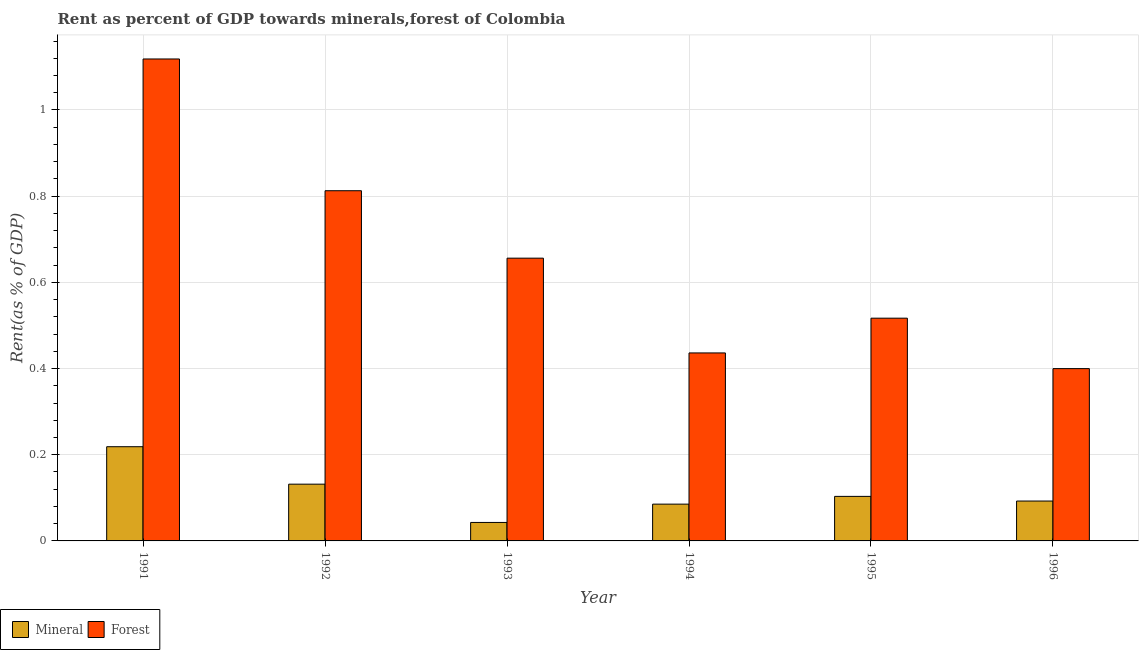How many different coloured bars are there?
Ensure brevity in your answer.  2. Are the number of bars on each tick of the X-axis equal?
Offer a very short reply. Yes. How many bars are there on the 2nd tick from the left?
Make the answer very short. 2. How many bars are there on the 2nd tick from the right?
Your response must be concise. 2. In how many cases, is the number of bars for a given year not equal to the number of legend labels?
Keep it short and to the point. 0. What is the mineral rent in 1992?
Keep it short and to the point. 0.13. Across all years, what is the maximum mineral rent?
Your answer should be compact. 0.22. Across all years, what is the minimum forest rent?
Offer a terse response. 0.4. In which year was the mineral rent maximum?
Ensure brevity in your answer.  1991. In which year was the forest rent minimum?
Your answer should be compact. 1996. What is the total mineral rent in the graph?
Provide a short and direct response. 0.67. What is the difference between the forest rent in 1994 and that in 1995?
Keep it short and to the point. -0.08. What is the difference between the forest rent in 1991 and the mineral rent in 1992?
Your answer should be compact. 0.31. What is the average forest rent per year?
Offer a very short reply. 0.66. What is the ratio of the forest rent in 1992 to that in 1994?
Your response must be concise. 1.86. Is the mineral rent in 1993 less than that in 1994?
Offer a terse response. Yes. Is the difference between the forest rent in 1991 and 1996 greater than the difference between the mineral rent in 1991 and 1996?
Provide a succinct answer. No. What is the difference between the highest and the second highest mineral rent?
Provide a succinct answer. 0.09. What is the difference between the highest and the lowest mineral rent?
Keep it short and to the point. 0.18. Is the sum of the mineral rent in 1991 and 1994 greater than the maximum forest rent across all years?
Give a very brief answer. Yes. What does the 2nd bar from the left in 1994 represents?
Give a very brief answer. Forest. What does the 2nd bar from the right in 1996 represents?
Offer a very short reply. Mineral. Are all the bars in the graph horizontal?
Your response must be concise. No. How many years are there in the graph?
Make the answer very short. 6. Are the values on the major ticks of Y-axis written in scientific E-notation?
Ensure brevity in your answer.  No. What is the title of the graph?
Offer a very short reply. Rent as percent of GDP towards minerals,forest of Colombia. Does "% of gross capital formation" appear as one of the legend labels in the graph?
Provide a short and direct response. No. What is the label or title of the Y-axis?
Give a very brief answer. Rent(as % of GDP). What is the Rent(as % of GDP) of Mineral in 1991?
Give a very brief answer. 0.22. What is the Rent(as % of GDP) in Forest in 1991?
Offer a terse response. 1.12. What is the Rent(as % of GDP) in Mineral in 1992?
Provide a succinct answer. 0.13. What is the Rent(as % of GDP) in Forest in 1992?
Provide a short and direct response. 0.81. What is the Rent(as % of GDP) in Mineral in 1993?
Provide a succinct answer. 0.04. What is the Rent(as % of GDP) of Forest in 1993?
Provide a short and direct response. 0.66. What is the Rent(as % of GDP) in Mineral in 1994?
Offer a very short reply. 0.09. What is the Rent(as % of GDP) of Forest in 1994?
Offer a terse response. 0.44. What is the Rent(as % of GDP) of Mineral in 1995?
Your response must be concise. 0.1. What is the Rent(as % of GDP) of Forest in 1995?
Provide a succinct answer. 0.52. What is the Rent(as % of GDP) of Mineral in 1996?
Your response must be concise. 0.09. What is the Rent(as % of GDP) in Forest in 1996?
Offer a very short reply. 0.4. Across all years, what is the maximum Rent(as % of GDP) of Mineral?
Keep it short and to the point. 0.22. Across all years, what is the maximum Rent(as % of GDP) in Forest?
Your answer should be compact. 1.12. Across all years, what is the minimum Rent(as % of GDP) in Mineral?
Provide a succinct answer. 0.04. Across all years, what is the minimum Rent(as % of GDP) in Forest?
Offer a terse response. 0.4. What is the total Rent(as % of GDP) in Mineral in the graph?
Make the answer very short. 0.67. What is the total Rent(as % of GDP) in Forest in the graph?
Your response must be concise. 3.94. What is the difference between the Rent(as % of GDP) of Mineral in 1991 and that in 1992?
Offer a very short reply. 0.09. What is the difference between the Rent(as % of GDP) in Forest in 1991 and that in 1992?
Your response must be concise. 0.31. What is the difference between the Rent(as % of GDP) of Mineral in 1991 and that in 1993?
Offer a very short reply. 0.18. What is the difference between the Rent(as % of GDP) in Forest in 1991 and that in 1993?
Offer a very short reply. 0.46. What is the difference between the Rent(as % of GDP) in Mineral in 1991 and that in 1994?
Offer a very short reply. 0.13. What is the difference between the Rent(as % of GDP) of Forest in 1991 and that in 1994?
Your response must be concise. 0.68. What is the difference between the Rent(as % of GDP) of Mineral in 1991 and that in 1995?
Give a very brief answer. 0.12. What is the difference between the Rent(as % of GDP) in Forest in 1991 and that in 1995?
Keep it short and to the point. 0.6. What is the difference between the Rent(as % of GDP) in Mineral in 1991 and that in 1996?
Your answer should be compact. 0.13. What is the difference between the Rent(as % of GDP) of Forest in 1991 and that in 1996?
Offer a terse response. 0.72. What is the difference between the Rent(as % of GDP) of Mineral in 1992 and that in 1993?
Your answer should be very brief. 0.09. What is the difference between the Rent(as % of GDP) of Forest in 1992 and that in 1993?
Ensure brevity in your answer.  0.16. What is the difference between the Rent(as % of GDP) of Mineral in 1992 and that in 1994?
Your response must be concise. 0.05. What is the difference between the Rent(as % of GDP) of Forest in 1992 and that in 1994?
Ensure brevity in your answer.  0.38. What is the difference between the Rent(as % of GDP) of Mineral in 1992 and that in 1995?
Keep it short and to the point. 0.03. What is the difference between the Rent(as % of GDP) in Forest in 1992 and that in 1995?
Keep it short and to the point. 0.3. What is the difference between the Rent(as % of GDP) in Mineral in 1992 and that in 1996?
Offer a terse response. 0.04. What is the difference between the Rent(as % of GDP) in Forest in 1992 and that in 1996?
Provide a short and direct response. 0.41. What is the difference between the Rent(as % of GDP) in Mineral in 1993 and that in 1994?
Ensure brevity in your answer.  -0.04. What is the difference between the Rent(as % of GDP) of Forest in 1993 and that in 1994?
Ensure brevity in your answer.  0.22. What is the difference between the Rent(as % of GDP) of Mineral in 1993 and that in 1995?
Offer a very short reply. -0.06. What is the difference between the Rent(as % of GDP) in Forest in 1993 and that in 1995?
Keep it short and to the point. 0.14. What is the difference between the Rent(as % of GDP) of Mineral in 1993 and that in 1996?
Your response must be concise. -0.05. What is the difference between the Rent(as % of GDP) of Forest in 1993 and that in 1996?
Offer a very short reply. 0.26. What is the difference between the Rent(as % of GDP) in Mineral in 1994 and that in 1995?
Give a very brief answer. -0.02. What is the difference between the Rent(as % of GDP) in Forest in 1994 and that in 1995?
Make the answer very short. -0.08. What is the difference between the Rent(as % of GDP) in Mineral in 1994 and that in 1996?
Ensure brevity in your answer.  -0.01. What is the difference between the Rent(as % of GDP) of Forest in 1994 and that in 1996?
Your response must be concise. 0.04. What is the difference between the Rent(as % of GDP) of Mineral in 1995 and that in 1996?
Your answer should be very brief. 0.01. What is the difference between the Rent(as % of GDP) of Forest in 1995 and that in 1996?
Give a very brief answer. 0.12. What is the difference between the Rent(as % of GDP) in Mineral in 1991 and the Rent(as % of GDP) in Forest in 1992?
Offer a very short reply. -0.59. What is the difference between the Rent(as % of GDP) in Mineral in 1991 and the Rent(as % of GDP) in Forest in 1993?
Offer a terse response. -0.44. What is the difference between the Rent(as % of GDP) of Mineral in 1991 and the Rent(as % of GDP) of Forest in 1994?
Your answer should be very brief. -0.22. What is the difference between the Rent(as % of GDP) in Mineral in 1991 and the Rent(as % of GDP) in Forest in 1995?
Provide a succinct answer. -0.3. What is the difference between the Rent(as % of GDP) of Mineral in 1991 and the Rent(as % of GDP) of Forest in 1996?
Keep it short and to the point. -0.18. What is the difference between the Rent(as % of GDP) of Mineral in 1992 and the Rent(as % of GDP) of Forest in 1993?
Provide a succinct answer. -0.52. What is the difference between the Rent(as % of GDP) in Mineral in 1992 and the Rent(as % of GDP) in Forest in 1994?
Provide a succinct answer. -0.3. What is the difference between the Rent(as % of GDP) of Mineral in 1992 and the Rent(as % of GDP) of Forest in 1995?
Provide a succinct answer. -0.39. What is the difference between the Rent(as % of GDP) in Mineral in 1992 and the Rent(as % of GDP) in Forest in 1996?
Provide a short and direct response. -0.27. What is the difference between the Rent(as % of GDP) of Mineral in 1993 and the Rent(as % of GDP) of Forest in 1994?
Offer a very short reply. -0.39. What is the difference between the Rent(as % of GDP) in Mineral in 1993 and the Rent(as % of GDP) in Forest in 1995?
Ensure brevity in your answer.  -0.47. What is the difference between the Rent(as % of GDP) in Mineral in 1993 and the Rent(as % of GDP) in Forest in 1996?
Your response must be concise. -0.36. What is the difference between the Rent(as % of GDP) in Mineral in 1994 and the Rent(as % of GDP) in Forest in 1995?
Your response must be concise. -0.43. What is the difference between the Rent(as % of GDP) in Mineral in 1994 and the Rent(as % of GDP) in Forest in 1996?
Keep it short and to the point. -0.31. What is the difference between the Rent(as % of GDP) in Mineral in 1995 and the Rent(as % of GDP) in Forest in 1996?
Provide a succinct answer. -0.3. What is the average Rent(as % of GDP) of Mineral per year?
Provide a short and direct response. 0.11. What is the average Rent(as % of GDP) in Forest per year?
Make the answer very short. 0.66. In the year 1991, what is the difference between the Rent(as % of GDP) in Mineral and Rent(as % of GDP) in Forest?
Offer a terse response. -0.9. In the year 1992, what is the difference between the Rent(as % of GDP) in Mineral and Rent(as % of GDP) in Forest?
Keep it short and to the point. -0.68. In the year 1993, what is the difference between the Rent(as % of GDP) of Mineral and Rent(as % of GDP) of Forest?
Offer a terse response. -0.61. In the year 1994, what is the difference between the Rent(as % of GDP) of Mineral and Rent(as % of GDP) of Forest?
Keep it short and to the point. -0.35. In the year 1995, what is the difference between the Rent(as % of GDP) in Mineral and Rent(as % of GDP) in Forest?
Ensure brevity in your answer.  -0.41. In the year 1996, what is the difference between the Rent(as % of GDP) in Mineral and Rent(as % of GDP) in Forest?
Your answer should be very brief. -0.31. What is the ratio of the Rent(as % of GDP) of Mineral in 1991 to that in 1992?
Ensure brevity in your answer.  1.66. What is the ratio of the Rent(as % of GDP) in Forest in 1991 to that in 1992?
Make the answer very short. 1.38. What is the ratio of the Rent(as % of GDP) of Mineral in 1991 to that in 1993?
Give a very brief answer. 5.1. What is the ratio of the Rent(as % of GDP) in Forest in 1991 to that in 1993?
Your response must be concise. 1.7. What is the ratio of the Rent(as % of GDP) in Mineral in 1991 to that in 1994?
Provide a short and direct response. 2.56. What is the ratio of the Rent(as % of GDP) in Forest in 1991 to that in 1994?
Make the answer very short. 2.56. What is the ratio of the Rent(as % of GDP) of Mineral in 1991 to that in 1995?
Your answer should be compact. 2.12. What is the ratio of the Rent(as % of GDP) in Forest in 1991 to that in 1995?
Give a very brief answer. 2.16. What is the ratio of the Rent(as % of GDP) in Mineral in 1991 to that in 1996?
Your answer should be compact. 2.36. What is the ratio of the Rent(as % of GDP) in Forest in 1991 to that in 1996?
Offer a terse response. 2.8. What is the ratio of the Rent(as % of GDP) in Mineral in 1992 to that in 1993?
Make the answer very short. 3.07. What is the ratio of the Rent(as % of GDP) in Forest in 1992 to that in 1993?
Offer a very short reply. 1.24. What is the ratio of the Rent(as % of GDP) of Mineral in 1992 to that in 1994?
Your response must be concise. 1.54. What is the ratio of the Rent(as % of GDP) in Forest in 1992 to that in 1994?
Provide a succinct answer. 1.86. What is the ratio of the Rent(as % of GDP) in Mineral in 1992 to that in 1995?
Your answer should be compact. 1.27. What is the ratio of the Rent(as % of GDP) in Forest in 1992 to that in 1995?
Offer a very short reply. 1.57. What is the ratio of the Rent(as % of GDP) of Mineral in 1992 to that in 1996?
Give a very brief answer. 1.42. What is the ratio of the Rent(as % of GDP) in Forest in 1992 to that in 1996?
Your response must be concise. 2.03. What is the ratio of the Rent(as % of GDP) in Mineral in 1993 to that in 1994?
Keep it short and to the point. 0.5. What is the ratio of the Rent(as % of GDP) of Forest in 1993 to that in 1994?
Provide a short and direct response. 1.5. What is the ratio of the Rent(as % of GDP) in Mineral in 1993 to that in 1995?
Make the answer very short. 0.41. What is the ratio of the Rent(as % of GDP) in Forest in 1993 to that in 1995?
Keep it short and to the point. 1.27. What is the ratio of the Rent(as % of GDP) in Mineral in 1993 to that in 1996?
Keep it short and to the point. 0.46. What is the ratio of the Rent(as % of GDP) in Forest in 1993 to that in 1996?
Your answer should be compact. 1.64. What is the ratio of the Rent(as % of GDP) in Mineral in 1994 to that in 1995?
Keep it short and to the point. 0.83. What is the ratio of the Rent(as % of GDP) of Forest in 1994 to that in 1995?
Ensure brevity in your answer.  0.84. What is the ratio of the Rent(as % of GDP) in Mineral in 1994 to that in 1996?
Your answer should be compact. 0.92. What is the ratio of the Rent(as % of GDP) in Forest in 1994 to that in 1996?
Give a very brief answer. 1.09. What is the ratio of the Rent(as % of GDP) of Mineral in 1995 to that in 1996?
Your answer should be very brief. 1.12. What is the ratio of the Rent(as % of GDP) in Forest in 1995 to that in 1996?
Provide a succinct answer. 1.29. What is the difference between the highest and the second highest Rent(as % of GDP) in Mineral?
Keep it short and to the point. 0.09. What is the difference between the highest and the second highest Rent(as % of GDP) of Forest?
Offer a terse response. 0.31. What is the difference between the highest and the lowest Rent(as % of GDP) in Mineral?
Provide a short and direct response. 0.18. What is the difference between the highest and the lowest Rent(as % of GDP) of Forest?
Your response must be concise. 0.72. 